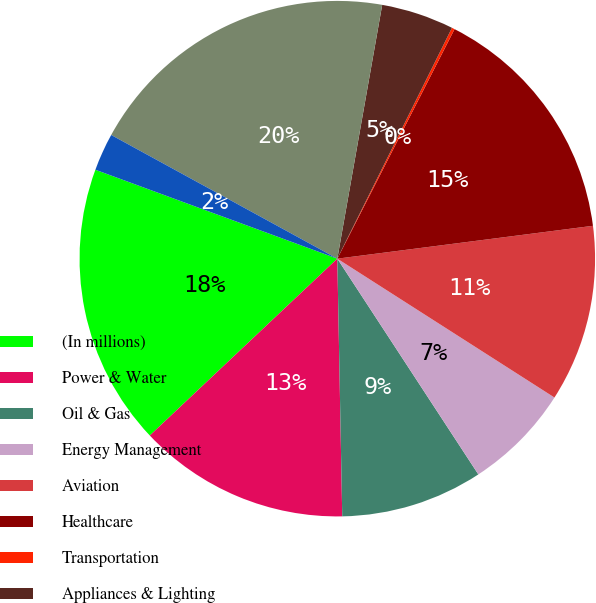Convert chart. <chart><loc_0><loc_0><loc_500><loc_500><pie_chart><fcel>(In millions)<fcel>Power & Water<fcel>Oil & Gas<fcel>Energy Management<fcel>Aviation<fcel>Healthcare<fcel>Transportation<fcel>Appliances & Lighting<fcel>GE Capital<fcel>Corporate items and<nl><fcel>17.64%<fcel>13.27%<fcel>8.91%<fcel>6.73%<fcel>11.09%<fcel>15.45%<fcel>0.18%<fcel>4.55%<fcel>19.82%<fcel>2.36%<nl></chart> 